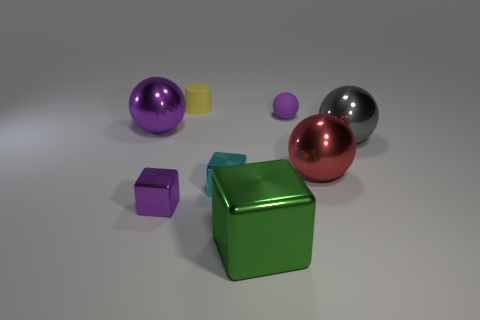There is a tiny metal cube left of the yellow matte cylinder; is its color the same as the sphere on the left side of the tiny cyan object?
Offer a very short reply. Yes. What is the shape of the small thing that is both to the left of the purple matte thing and behind the red sphere?
Your answer should be compact. Cylinder. Is there a small metal object that has the same shape as the yellow rubber thing?
Keep it short and to the point. No. The purple rubber thing that is the same size as the yellow object is what shape?
Provide a short and direct response. Sphere. What is the small ball made of?
Ensure brevity in your answer.  Rubber. There is a purple shiny object behind the shiny thing that is on the right side of the large metal ball that is in front of the gray object; what is its size?
Keep it short and to the point. Large. How many matte objects are green objects or brown spheres?
Make the answer very short. 0. What is the size of the purple matte ball?
Ensure brevity in your answer.  Small. How many things are either red balls or large balls that are right of the tiny purple block?
Give a very brief answer. 2. How many other things are the same color as the tiny rubber cylinder?
Ensure brevity in your answer.  0. 